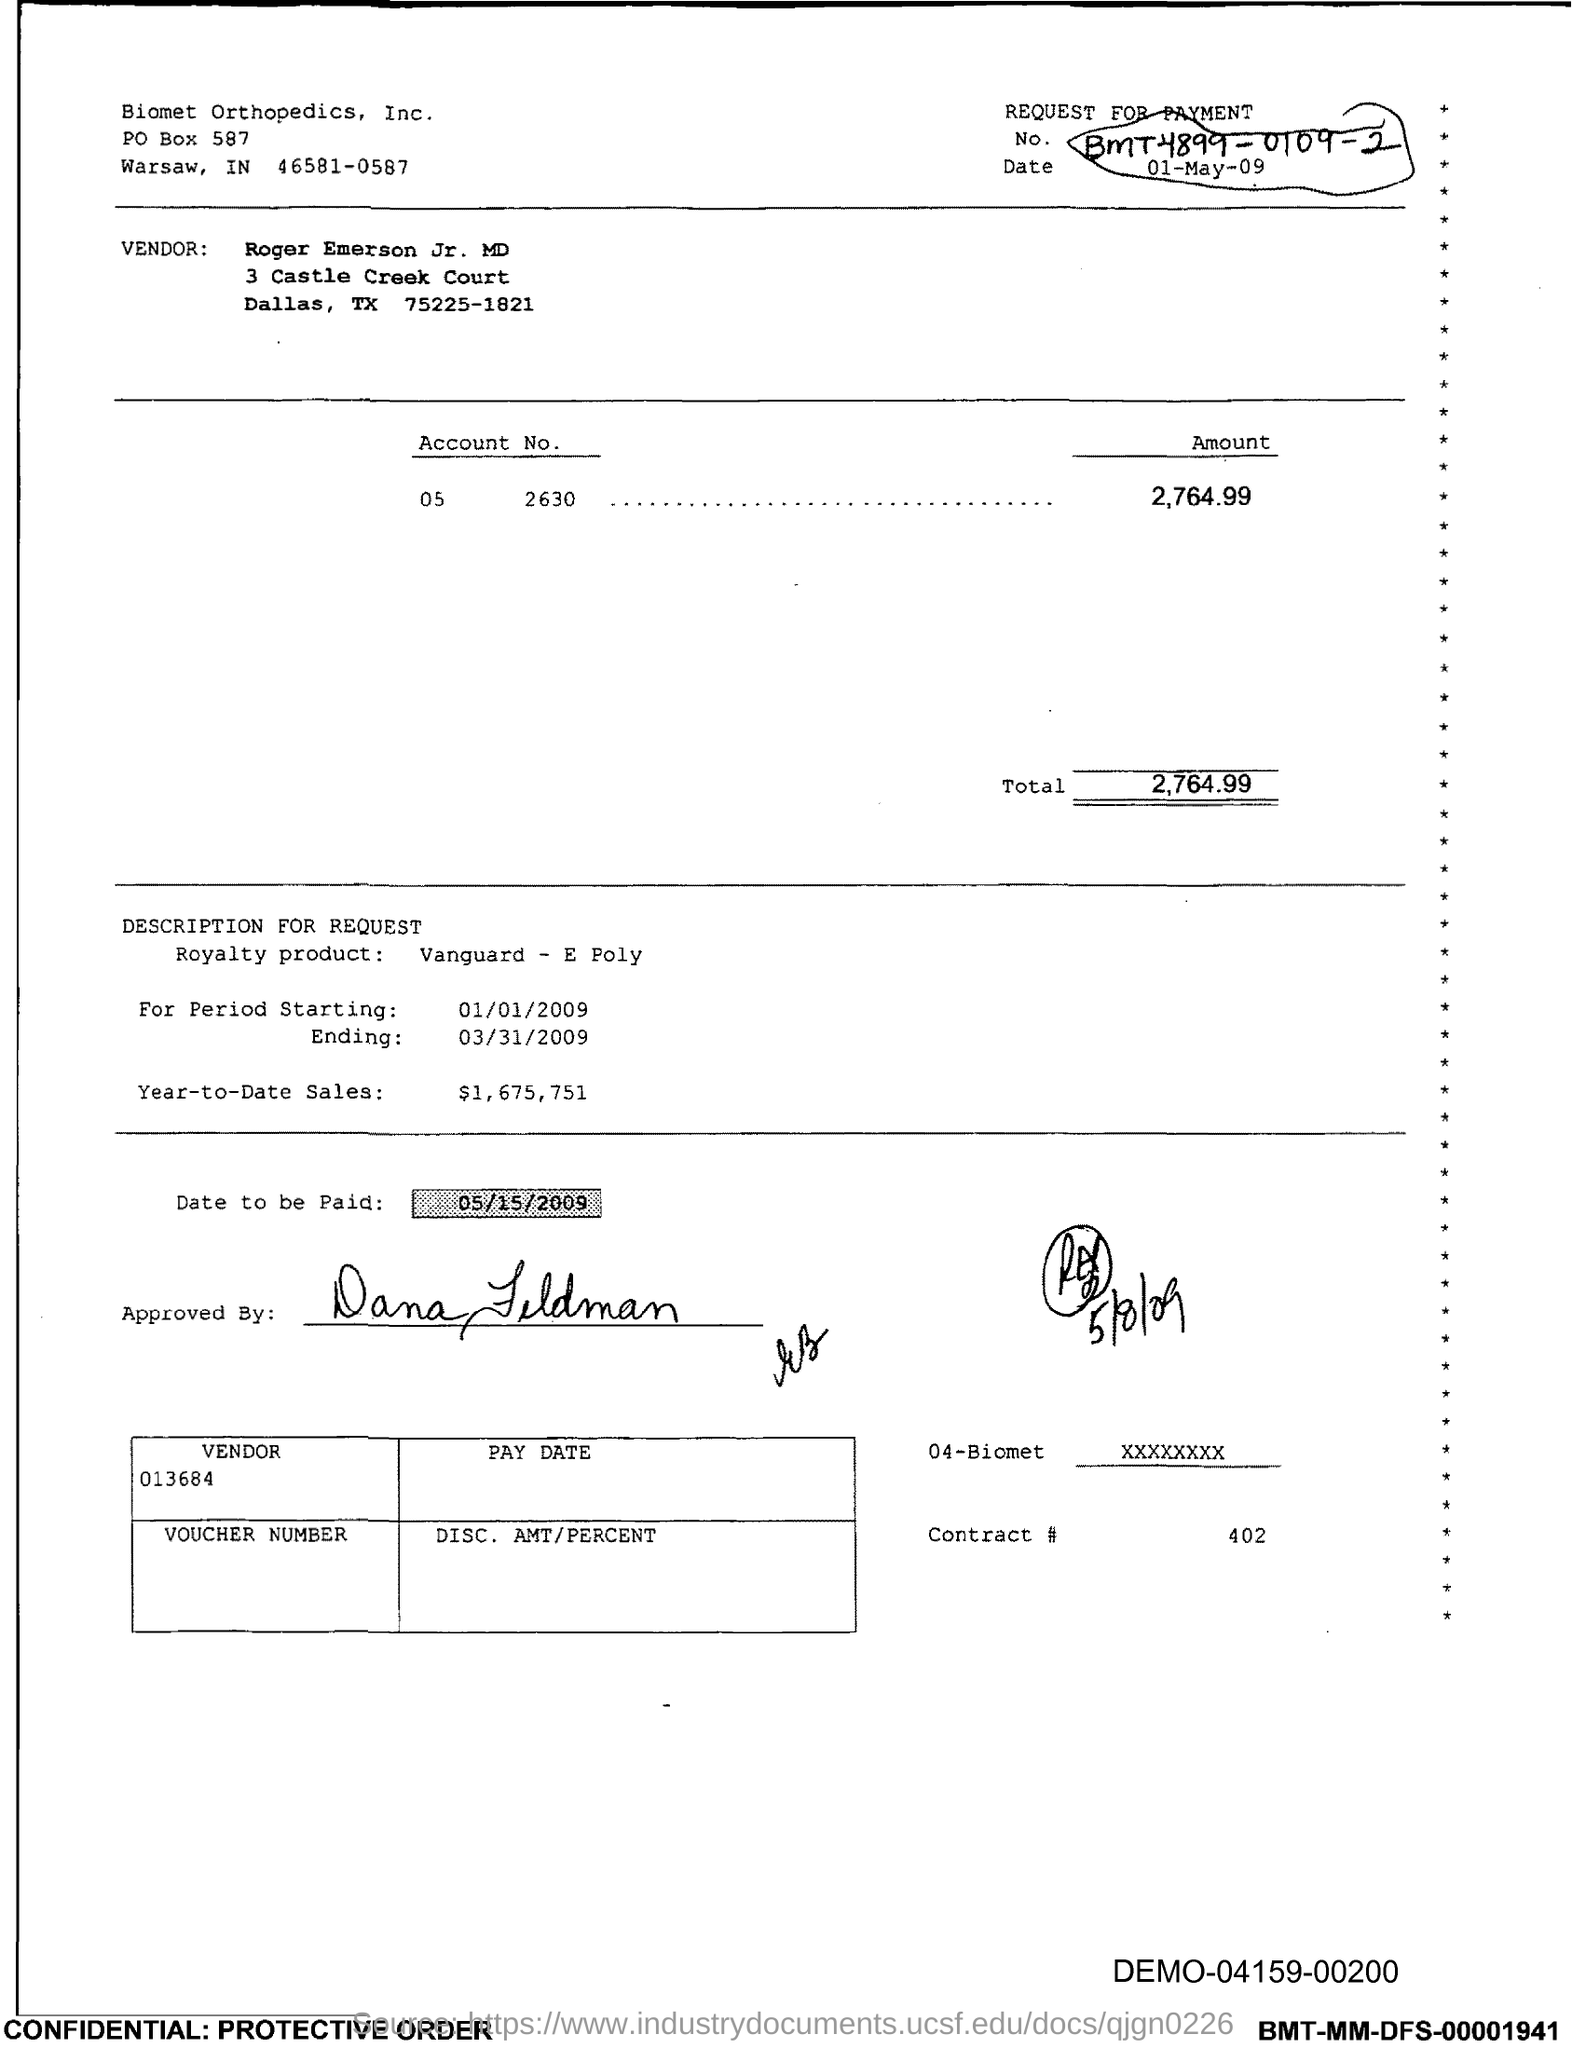Indicate a few pertinent items in this graphic. The total is 2,764.99. The contract number is 402. The PO Box number mentioned in the document is 587. 